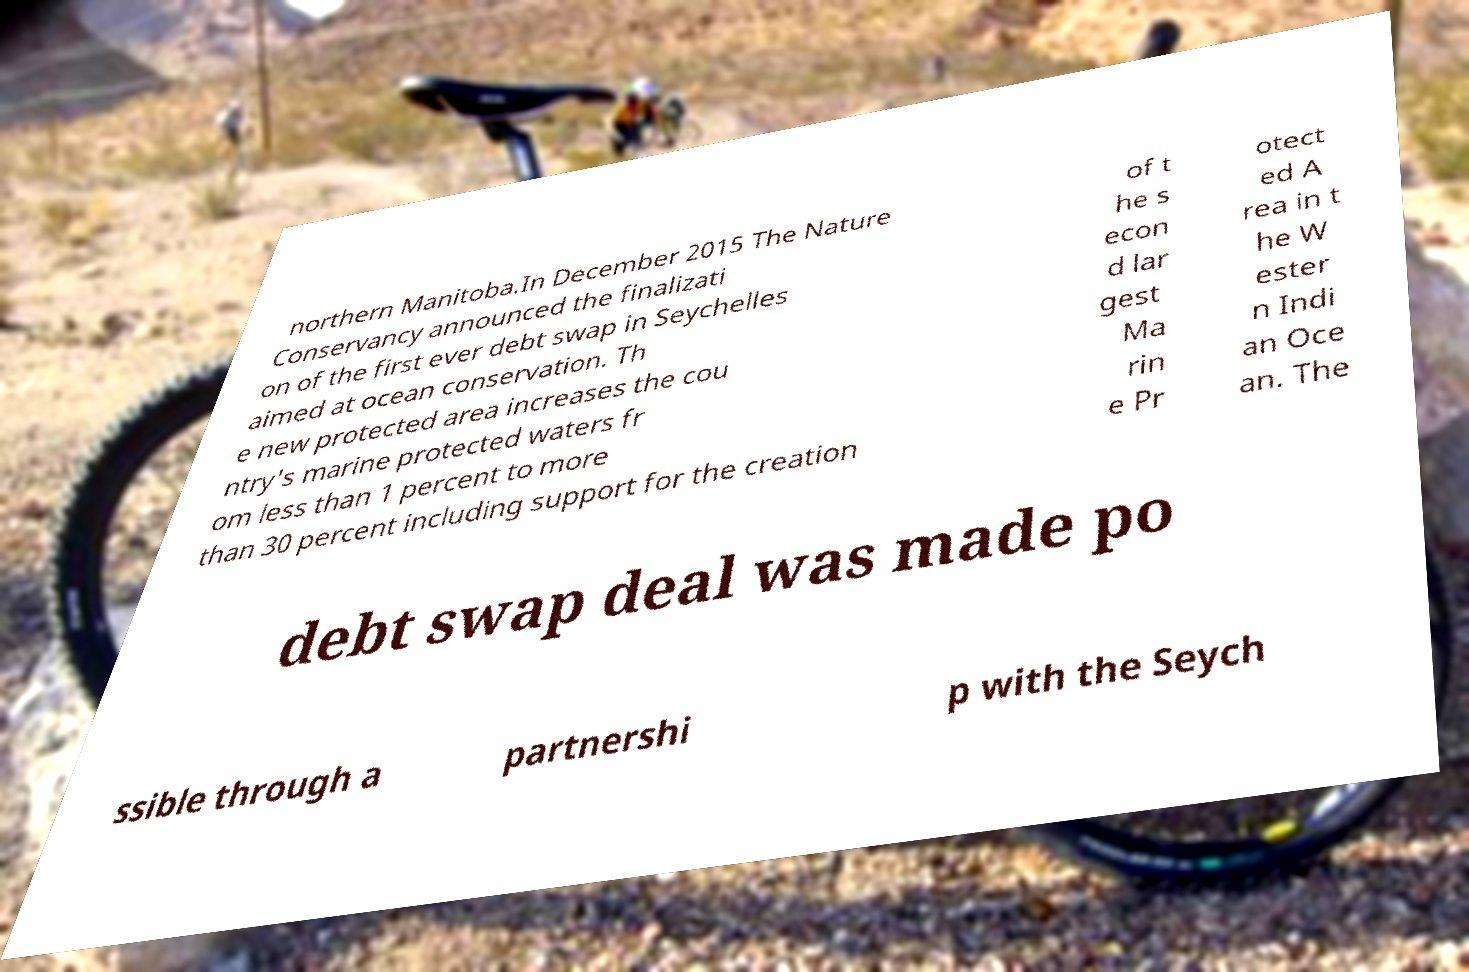Please identify and transcribe the text found in this image. northern Manitoba.In December 2015 The Nature Conservancy announced the finalizati on of the first ever debt swap in Seychelles aimed at ocean conservation. Th e new protected area increases the cou ntry's marine protected waters fr om less than 1 percent to more than 30 percent including support for the creation of t he s econ d lar gest Ma rin e Pr otect ed A rea in t he W ester n Indi an Oce an. The debt swap deal was made po ssible through a partnershi p with the Seych 